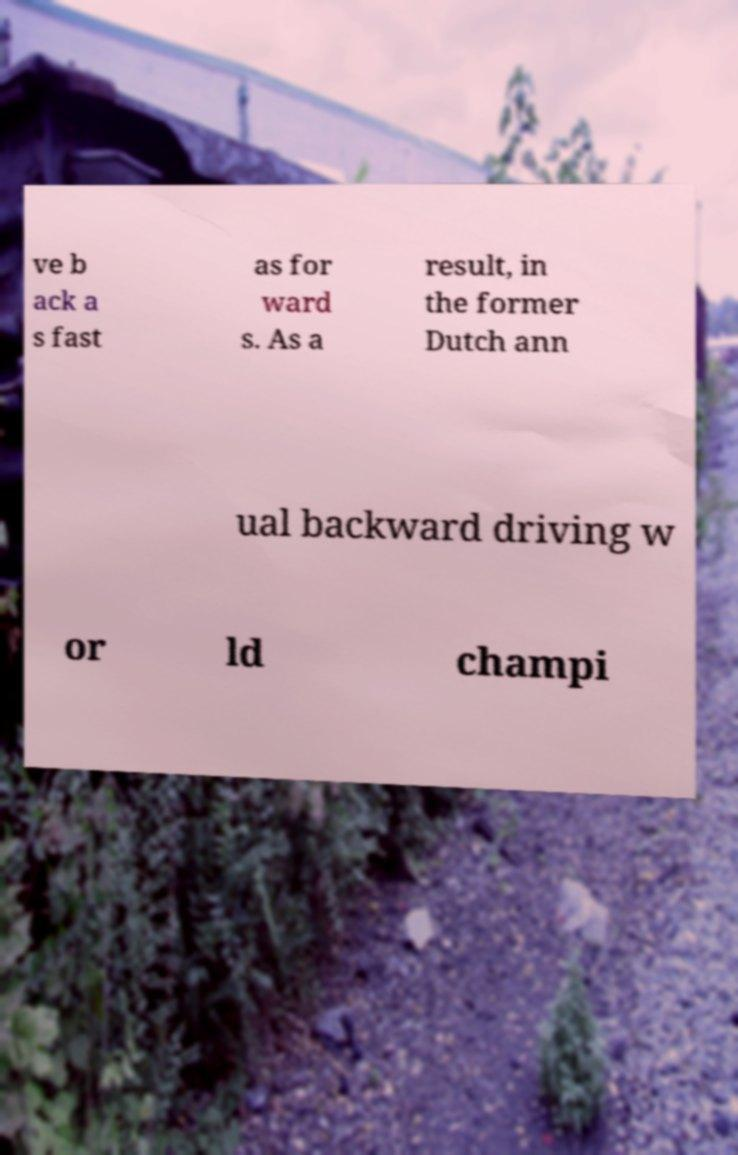There's text embedded in this image that I need extracted. Can you transcribe it verbatim? ve b ack a s fast as for ward s. As a result, in the former Dutch ann ual backward driving w or ld champi 